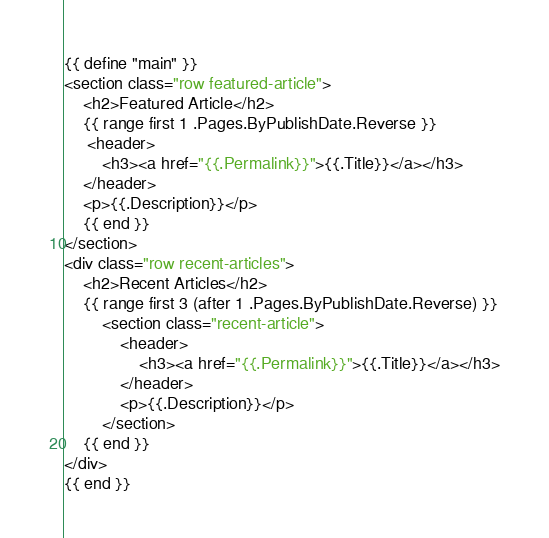Convert code to text. <code><loc_0><loc_0><loc_500><loc_500><_HTML_>{{ define "main" }}
<section class="row featured-article">
    <h2>Featured Article</h2>
    {{ range first 1 .Pages.ByPublishDate.Reverse }}
     <header>
        <h3><a href="{{.Permalink}}">{{.Title}}</a></h3>
    </header>
    <p>{{.Description}}</p>
    {{ end }}
</section>
<div class="row recent-articles">
    <h2>Recent Articles</h2>
    {{ range first 3 (after 1 .Pages.ByPublishDate.Reverse) }}
        <section class="recent-article">
            <header>
                <h3><a href="{{.Permalink}}">{{.Title}}</a></h3>
            </header>
            <p>{{.Description}}</p>
        </section>
    {{ end }}
</div>
{{ end }}</code> 